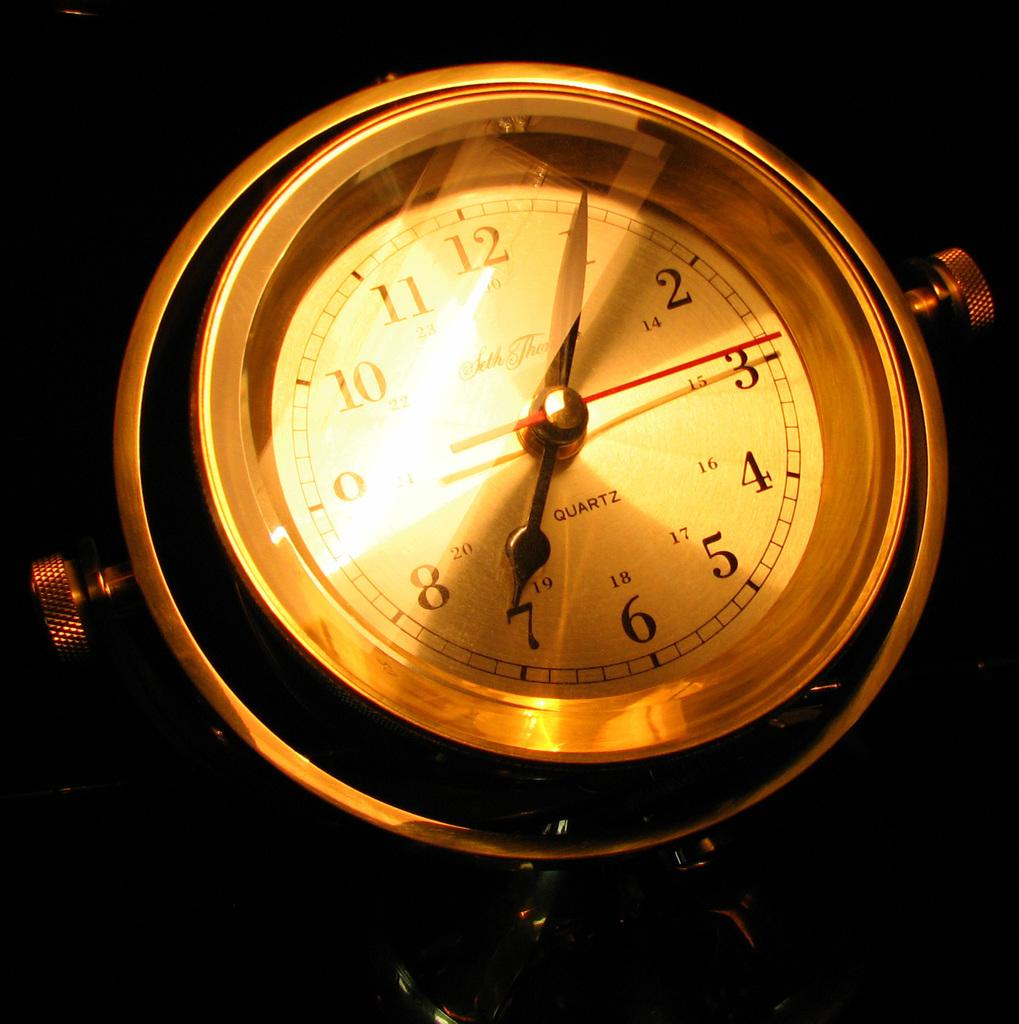Provide a one-sentence caption for the provided image. The clock shown in the image has a quartz movement. 